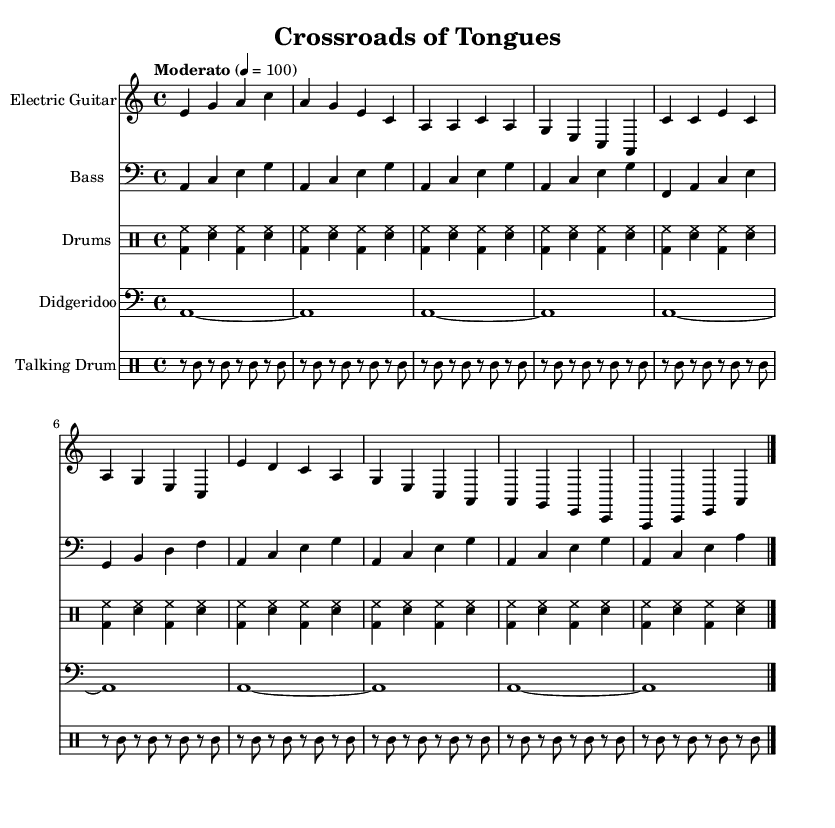What is the key signature of this music? The key signature indicates A minor, which has no sharps or flats. This can be determined by the presence of the "a" note and the absence of any accidentals in the signature.
Answer: A minor What is the time signature of this piece? The time signature is 4/4, which is indicated at the beginning of the score. This means there are four beats in a measure and the quarter note gets one beat.
Answer: 4/4 What tempo is indicated for this music? The tempo marking states "Moderato" with a metronome marking of 4 = 100, meaning the piece should be played at a moderate speed of 100 beats per minute.
Answer: 100 How many instruments are featured in this score? The score includes five instruments: Electric Guitar, Bass, Drums, Didgeridoo, and Talking Drum. This can be identified by counting the number of distinct staves in the score.
Answer: Five What type of rhythm pattern is primarily used in the drum part? The drum part features a simplified shuffle pattern, which is often characterized by a swing feel and syncopation. This can be observed in the alternating bass drum and snare hits throughout the measures.
Answer: Shuffle pattern What cultural element is incorporated into this blues piece? The score incorporates elements of world music through the inclusion of instruments like the Didgeridoo and the Talking Drum, which are significant to indigenous music traditions, reflecting a blend of blues with world music influences.
Answer: Indigenous instruments What is the starting note of the electric guitar's intro? The electric guitar's intro starts on the note E, as indicated by the first note in the measure.
Answer: E 